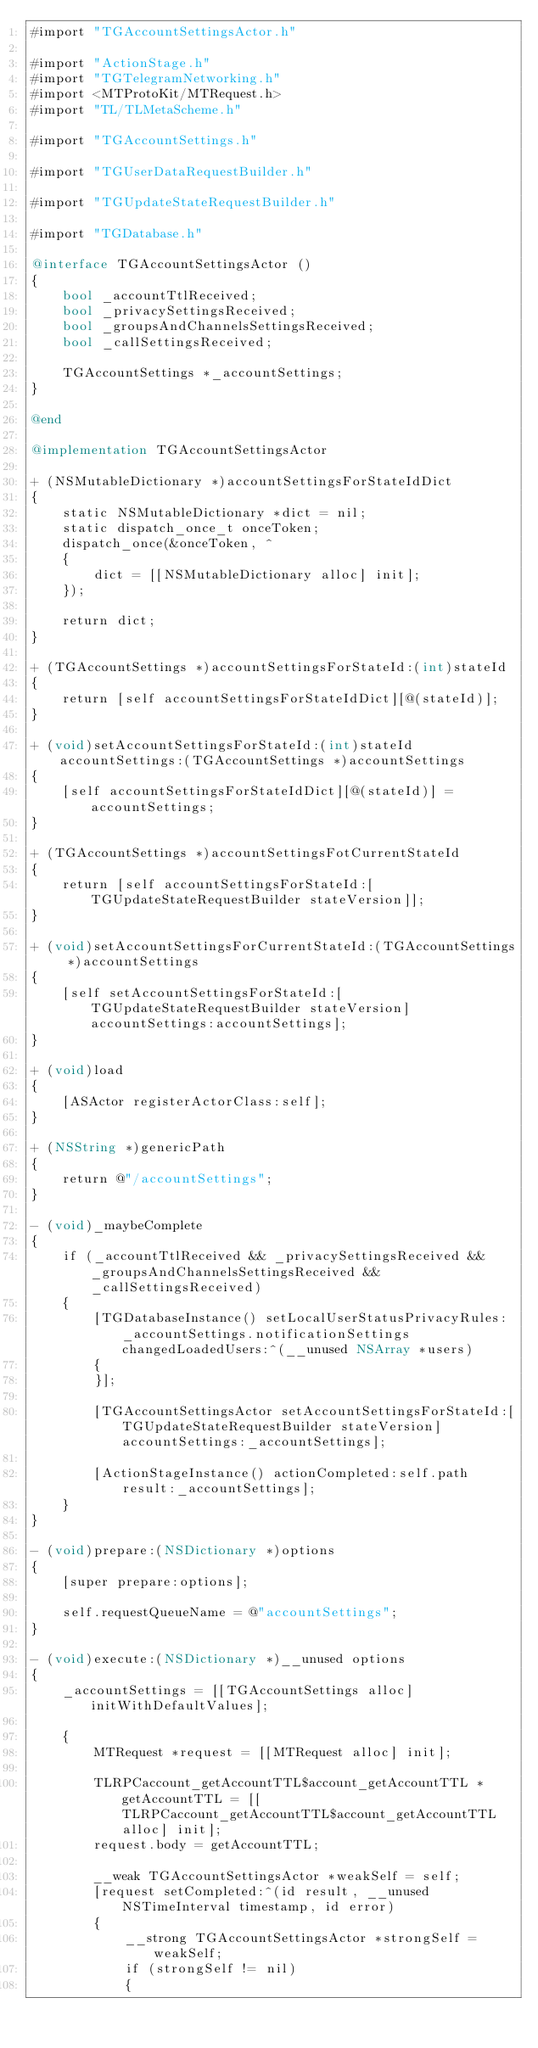<code> <loc_0><loc_0><loc_500><loc_500><_ObjectiveC_>#import "TGAccountSettingsActor.h"

#import "ActionStage.h"
#import "TGTelegramNetworking.h"
#import <MTProtoKit/MTRequest.h>
#import "TL/TLMetaScheme.h"

#import "TGAccountSettings.h"

#import "TGUserDataRequestBuilder.h"

#import "TGUpdateStateRequestBuilder.h"

#import "TGDatabase.h"

@interface TGAccountSettingsActor ()
{
    bool _accountTtlReceived;
    bool _privacySettingsReceived;
    bool _groupsAndChannelsSettingsReceived;
    bool _callSettingsReceived;
    
    TGAccountSettings *_accountSettings;
}

@end

@implementation TGAccountSettingsActor

+ (NSMutableDictionary *)accountSettingsForStateIdDict
{
    static NSMutableDictionary *dict = nil;
    static dispatch_once_t onceToken;
    dispatch_once(&onceToken, ^
    {
        dict = [[NSMutableDictionary alloc] init];
    });
    
    return dict;
}

+ (TGAccountSettings *)accountSettingsForStateId:(int)stateId
{
    return [self accountSettingsForStateIdDict][@(stateId)];
}

+ (void)setAccountSettingsForStateId:(int)stateId accountSettings:(TGAccountSettings *)accountSettings
{
    [self accountSettingsForStateIdDict][@(stateId)] = accountSettings;
}

+ (TGAccountSettings *)accountSettingsFotCurrentStateId
{
    return [self accountSettingsForStateId:[TGUpdateStateRequestBuilder stateVersion]];
}

+ (void)setAccountSettingsForCurrentStateId:(TGAccountSettings *)accountSettings
{
    [self setAccountSettingsForStateId:[TGUpdateStateRequestBuilder stateVersion] accountSettings:accountSettings];
}

+ (void)load
{
    [ASActor registerActorClass:self];
}

+ (NSString *)genericPath
{
    return @"/accountSettings";
}

- (void)_maybeComplete
{
    if (_accountTtlReceived && _privacySettingsReceived && _groupsAndChannelsSettingsReceived && _callSettingsReceived)
    {
        [TGDatabaseInstance() setLocalUserStatusPrivacyRules:_accountSettings.notificationSettings changedLoadedUsers:^(__unused NSArray *users)
        {
        }];
        
        [TGAccountSettingsActor setAccountSettingsForStateId:[TGUpdateStateRequestBuilder stateVersion] accountSettings:_accountSettings];
        
        [ActionStageInstance() actionCompleted:self.path result:_accountSettings];
    }
}

- (void)prepare:(NSDictionary *)options
{
    [super prepare:options];
    
    self.requestQueueName = @"accountSettings";
}

- (void)execute:(NSDictionary *)__unused options
{
    _accountSettings = [[TGAccountSettings alloc] initWithDefaultValues];
    
    {
        MTRequest *request = [[MTRequest alloc] init];
        
        TLRPCaccount_getAccountTTL$account_getAccountTTL *getAccountTTL = [[TLRPCaccount_getAccountTTL$account_getAccountTTL alloc] init];
        request.body = getAccountTTL;
        
        __weak TGAccountSettingsActor *weakSelf = self;
        [request setCompleted:^(id result, __unused NSTimeInterval timestamp, id error)
        {
            __strong TGAccountSettingsActor *strongSelf = weakSelf;
            if (strongSelf != nil)
            {</code> 